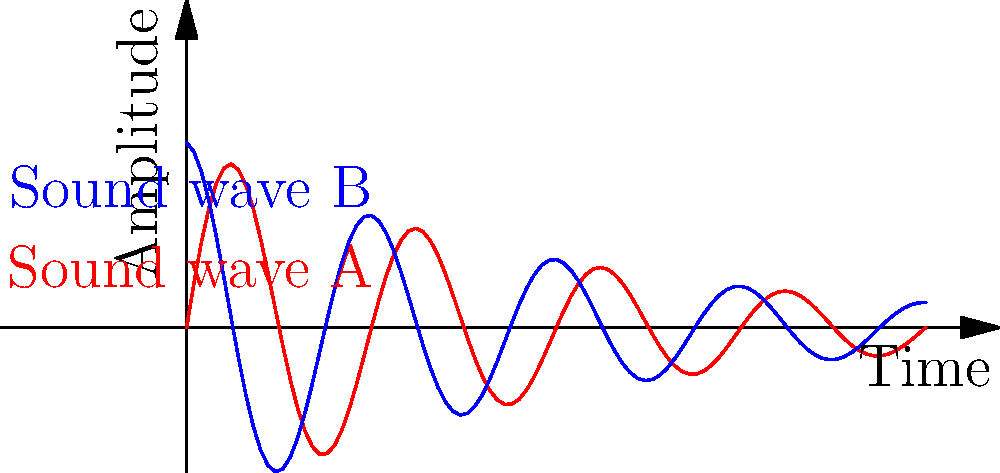Consider the surface created by overlapping the two sound waves A and B shown in the graph. If this surface is closed by connecting the endpoints, what is its Euler characteristic? Assume the surface has no self-intersections and forms a single connected component. To find the Euler characteristic of the surface, we'll follow these steps:

1) The Euler characteristic $\chi$ is given by the formula:
   $$\chi = V - E + F$$
   where $V$ is the number of vertices, $E$ is the number of edges, and $F$ is the number of faces.

2) In this case:
   - We have 2 vertices (the start and end points where the waves meet).
   - We have 3 edges (the two wave paths and the connection between endpoints).
   - We have 2 faces (the interior and exterior of the closed surface).

3) Plugging these values into the formula:
   $$\chi = 2 - 3 + 2 = 1$$

4) The Euler characteristic of 1 corresponds to a topological sphere.

5) This makes sense for a singer-songwriter, as the closed surface formed by these sound waves resembles a spherical resonance chamber, similar to those found in musical instruments or recording studios.
Answer: 1 